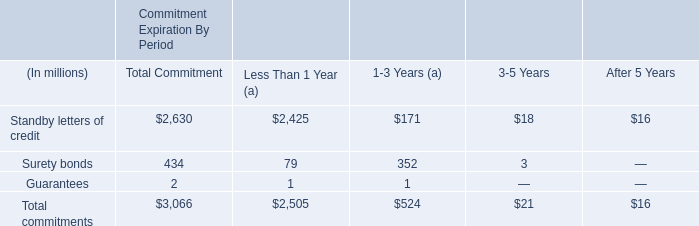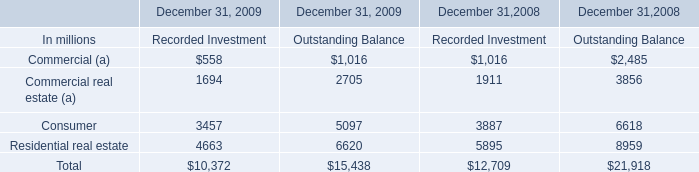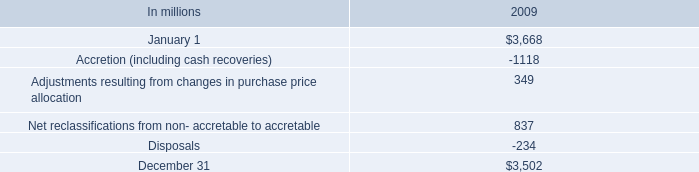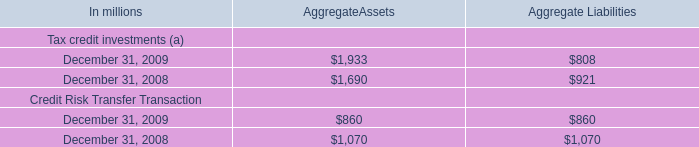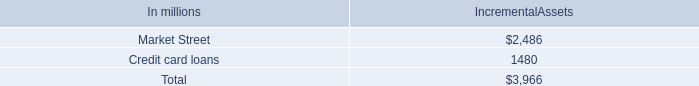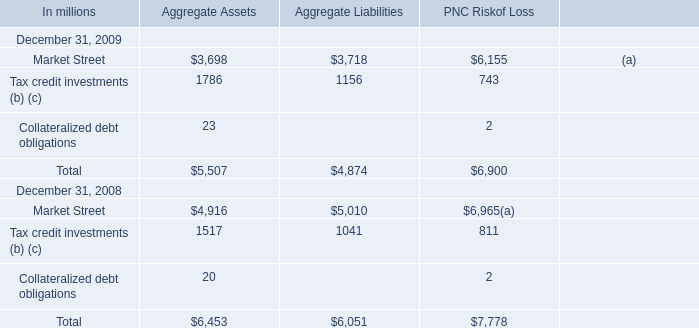Which year has the greatest proportion of Tax credit investments (b) (c) for Aggregate Assets? 
Answer: December 31, 2008. 